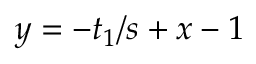Convert formula to latex. <formula><loc_0><loc_0><loc_500><loc_500>y = - t _ { 1 } / s + x - 1</formula> 